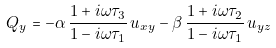Convert formula to latex. <formula><loc_0><loc_0><loc_500><loc_500>Q _ { y } & = - \alpha \, \frac { 1 + i \omega \tau _ { 3 } } { 1 - i \omega \tau _ { 1 } } \, u _ { x y } - \beta \, \frac { 1 + i \omega \tau _ { 2 } } { 1 - i \omega \tau _ { 1 } } \, u _ { y z } \,</formula> 